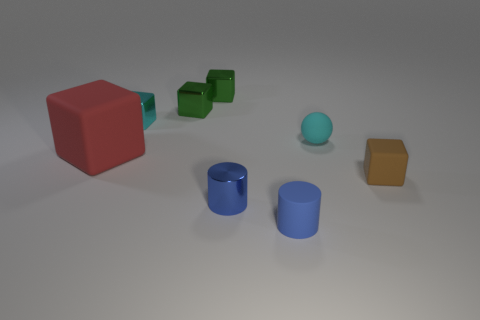There is another cylinder that is the same color as the metallic cylinder; what is its material?
Offer a terse response. Rubber. Does the small blue matte thing have the same shape as the large thing?
Ensure brevity in your answer.  No. What is the shape of the tiny matte object behind the tiny cube that is right of the blue metal object?
Provide a succinct answer. Sphere. Is there a green rubber thing?
Offer a terse response. No. There is a blue cylinder that is right of the metallic thing in front of the large thing; what number of cylinders are behind it?
Make the answer very short. 1. Do the brown matte object and the big object behind the brown rubber block have the same shape?
Your answer should be compact. Yes. Are there more small brown matte spheres than blue metallic cylinders?
Offer a terse response. No. Is there anything else that has the same size as the cyan rubber ball?
Ensure brevity in your answer.  Yes. There is a small thing that is on the right side of the rubber sphere; does it have the same shape as the large thing?
Your response must be concise. Yes. Is the number of cyan balls right of the cyan rubber thing greater than the number of large red matte things?
Your answer should be compact. No. 